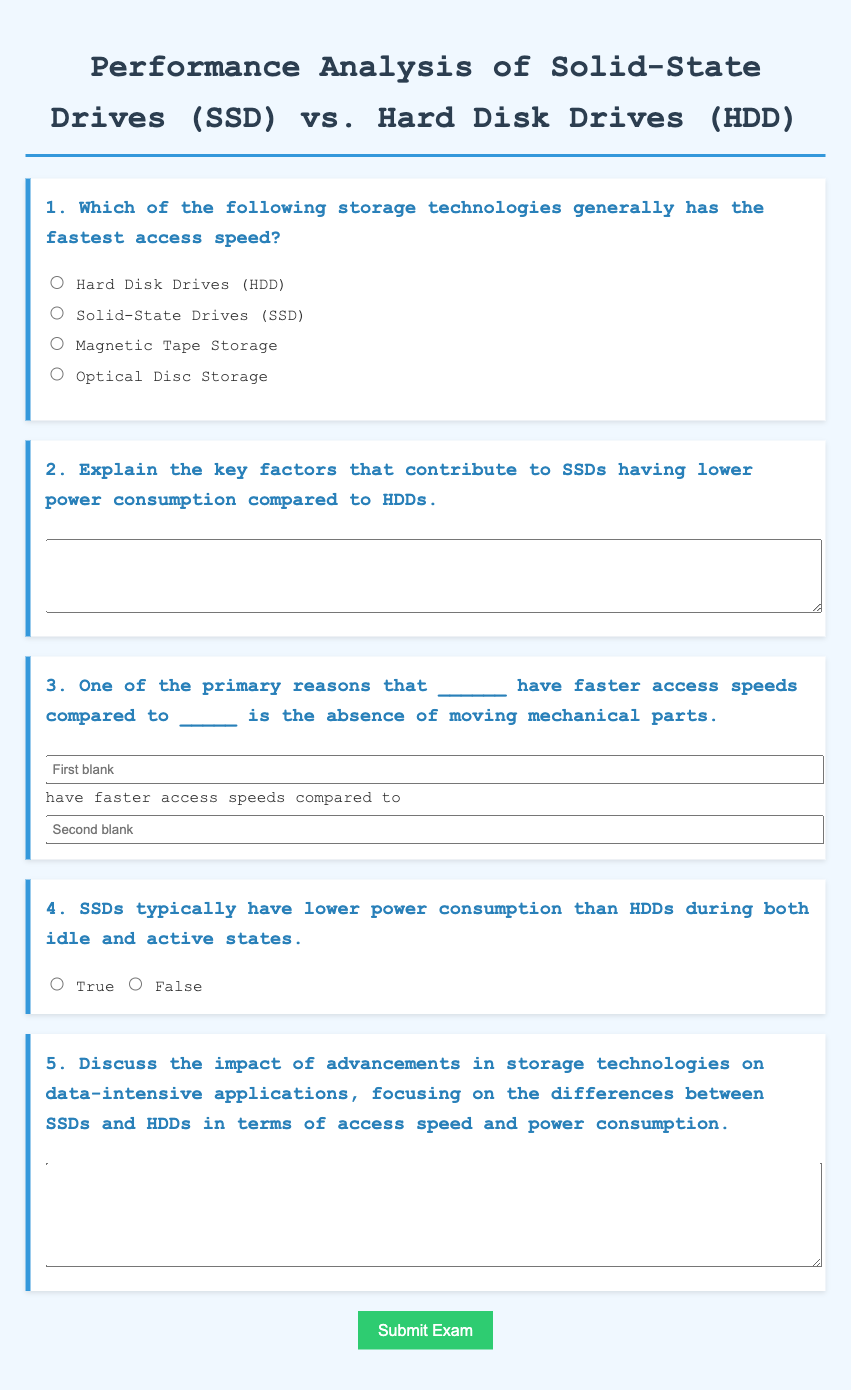Which storage technology has the fastest access speed? The document states that Solid-State Drives (SSD) generally have the fastest access speed compared to other technologies listed.
Answer: Solid-State Drives (SSD) What is one reason SSDs have faster access speeds than HDDs? The document mentions the absence of moving mechanical parts as a primary reason for faster access speeds in SSDs.
Answer: Absence of moving mechanical parts True or False: SSDs use more power than HDDs during idle states. The document indicates that SSDs typically have lower power consumption than HDDs during both idle and active states, implying the statement is false.
Answer: False What do SSDs and HDDs differ in terms of when discussing their performance characteristics? The document emphasizes access speed and power consumption as the primary differences between SSDs and HDDs.
Answer: Access speed and power consumption How many paragraphs are recommended for answering the question about advancements in storage technologies? The question suggests a length of six paragraphs for discussing the impact of advancements in storage on data-intensive applications.
Answer: Six paragraphs 